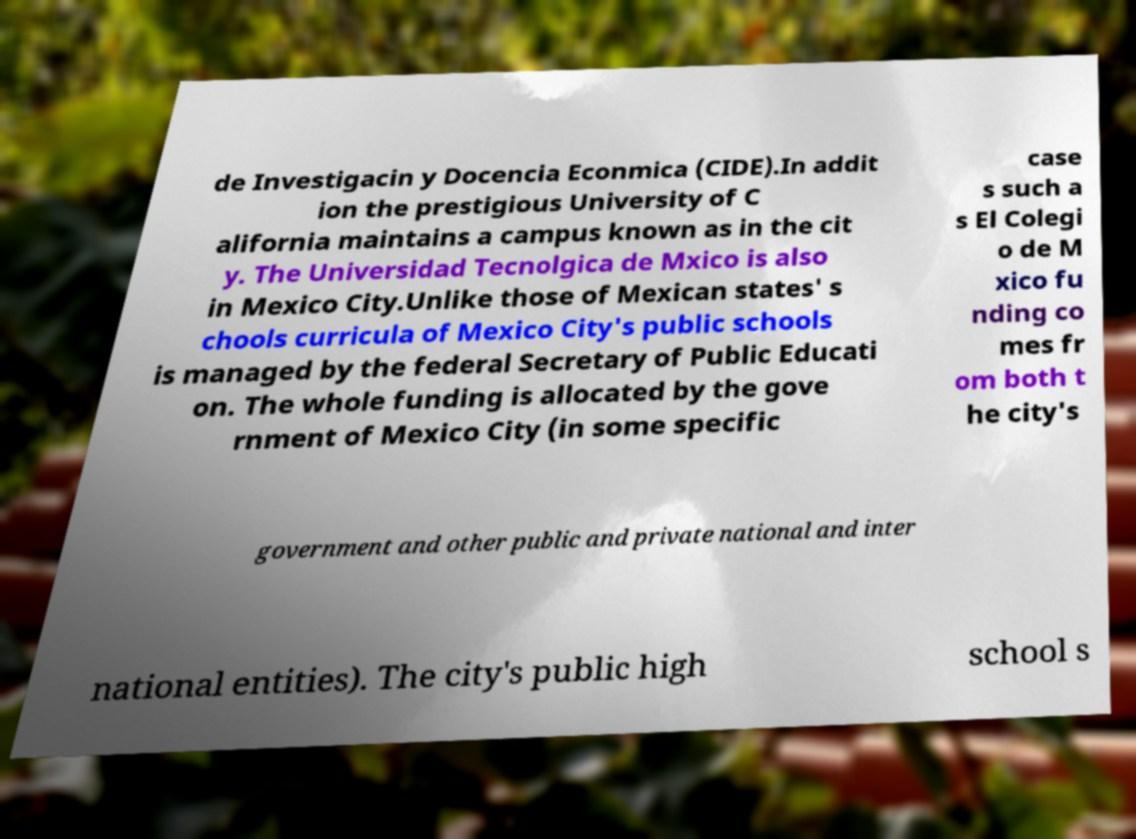Can you accurately transcribe the text from the provided image for me? de Investigacin y Docencia Econmica (CIDE).In addit ion the prestigious University of C alifornia maintains a campus known as in the cit y. The Universidad Tecnolgica de Mxico is also in Mexico City.Unlike those of Mexican states' s chools curricula of Mexico City's public schools is managed by the federal Secretary of Public Educati on. The whole funding is allocated by the gove rnment of Mexico City (in some specific case s such a s El Colegi o de M xico fu nding co mes fr om both t he city's government and other public and private national and inter national entities). The city's public high school s 